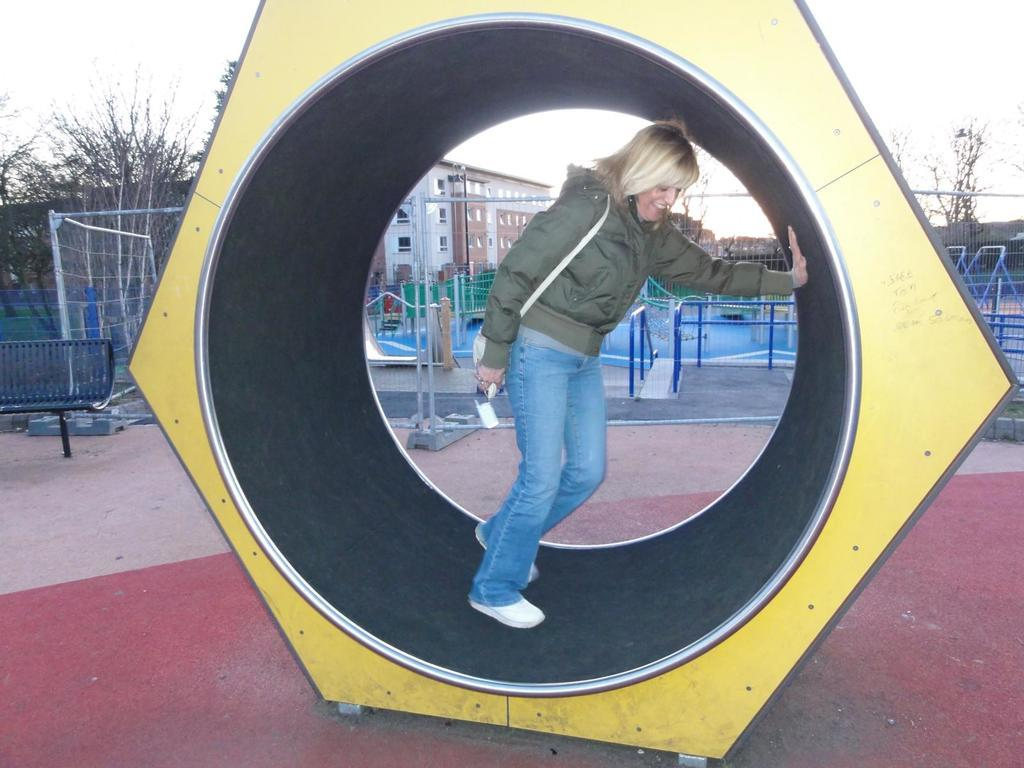What is the main subject of the image? There is a woman standing in the image. Where is the woman standing? The woman is standing on the floor. What other objects or structures can be seen in the image? There is a bench, grills, buildings, trees, and fences in the image. What part of the natural environment is visible in the image? The sky is visible in the image. What type of structure is the woman using to express her desire for a turkey in the image? There is no structure or mention of a turkey in the image; it features a woman standing with various objects and structures around her. 